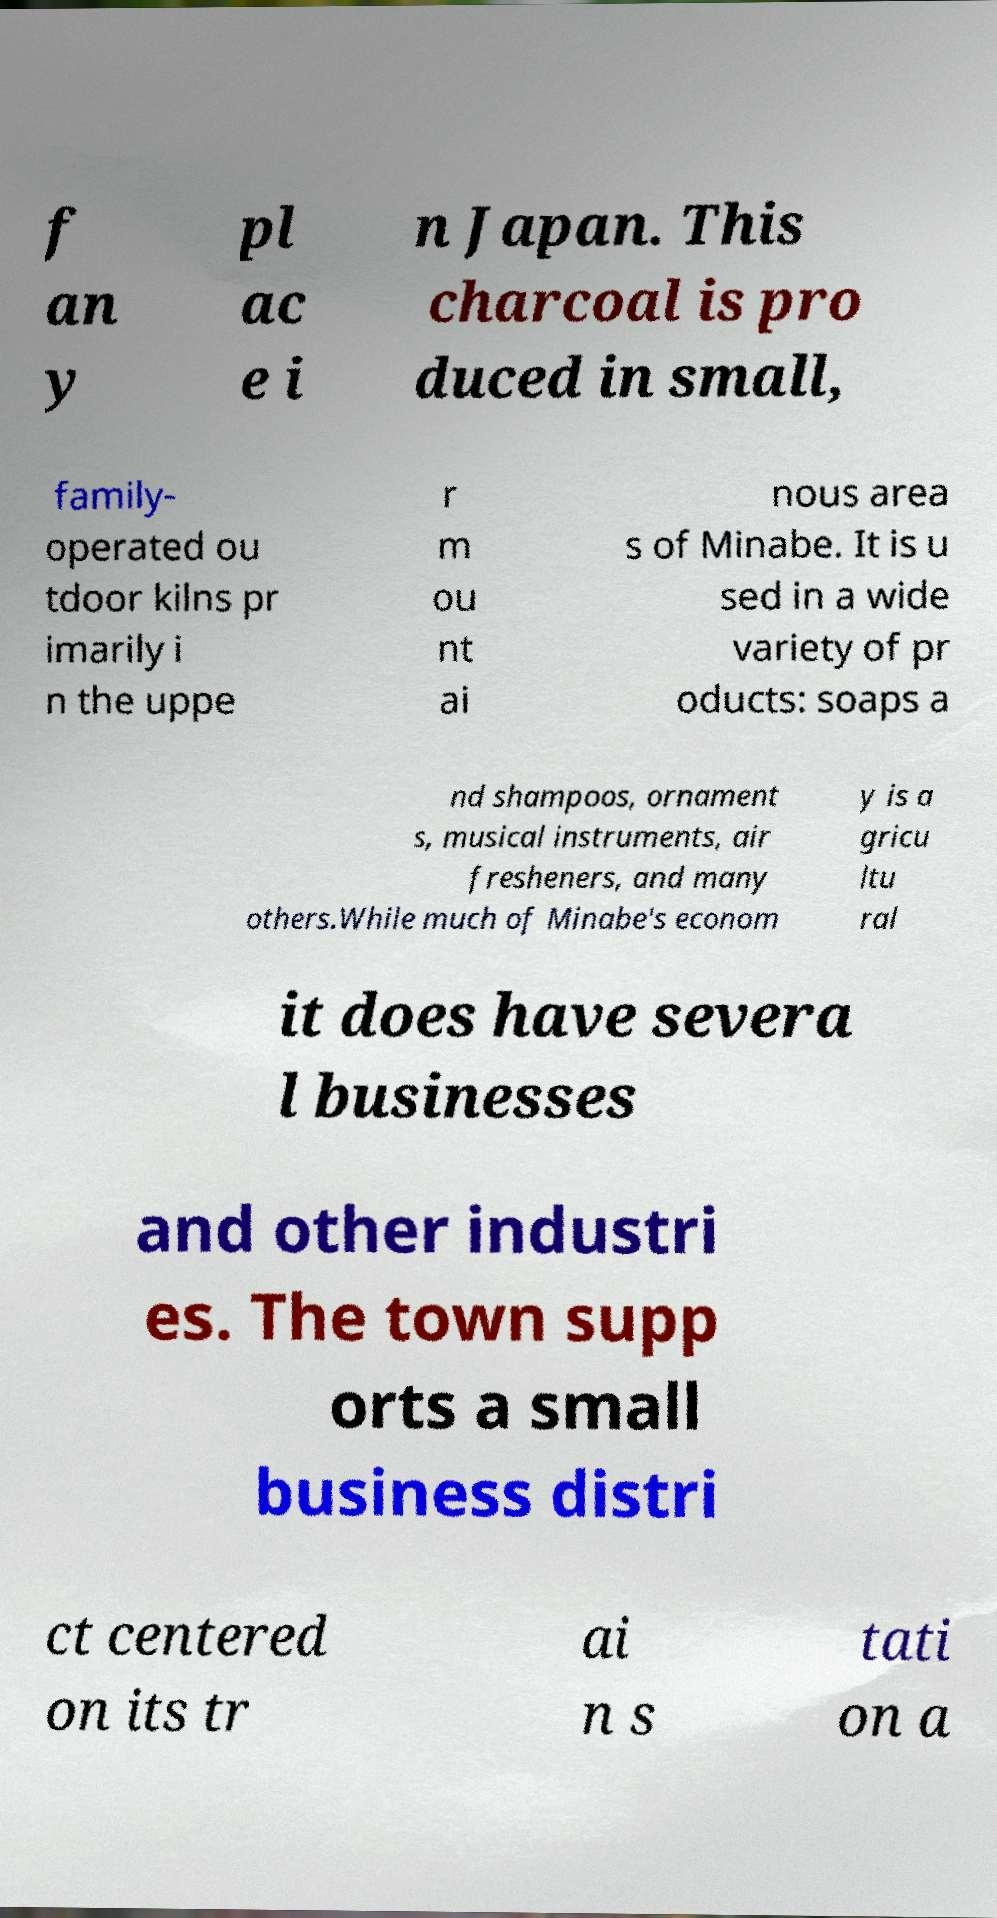Please read and relay the text visible in this image. What does it say? f an y pl ac e i n Japan. This charcoal is pro duced in small, family- operated ou tdoor kilns pr imarily i n the uppe r m ou nt ai nous area s of Minabe. It is u sed in a wide variety of pr oducts: soaps a nd shampoos, ornament s, musical instruments, air fresheners, and many others.While much of Minabe's econom y is a gricu ltu ral it does have severa l businesses and other industri es. The town supp orts a small business distri ct centered on its tr ai n s tati on a 